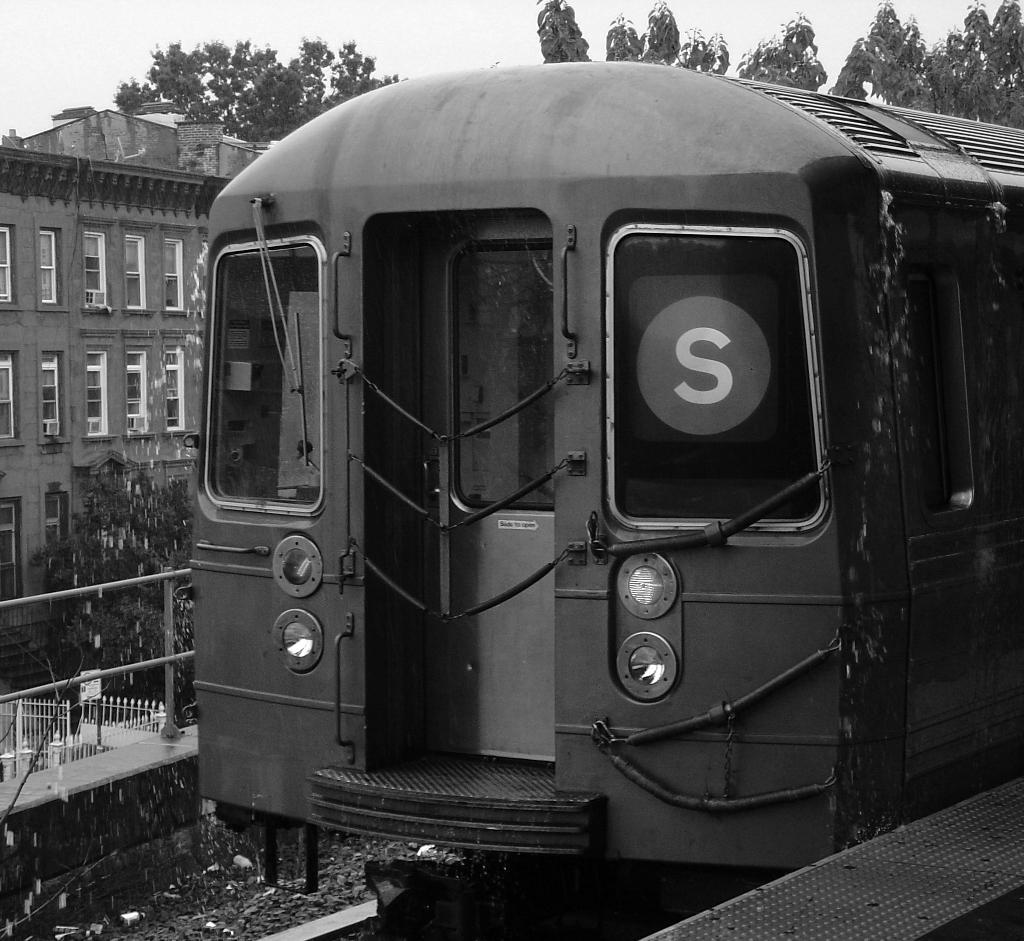In one or two sentences, can you explain what this image depicts? As we can see in the image there is train, railway track, fence, trees, building and sky. 